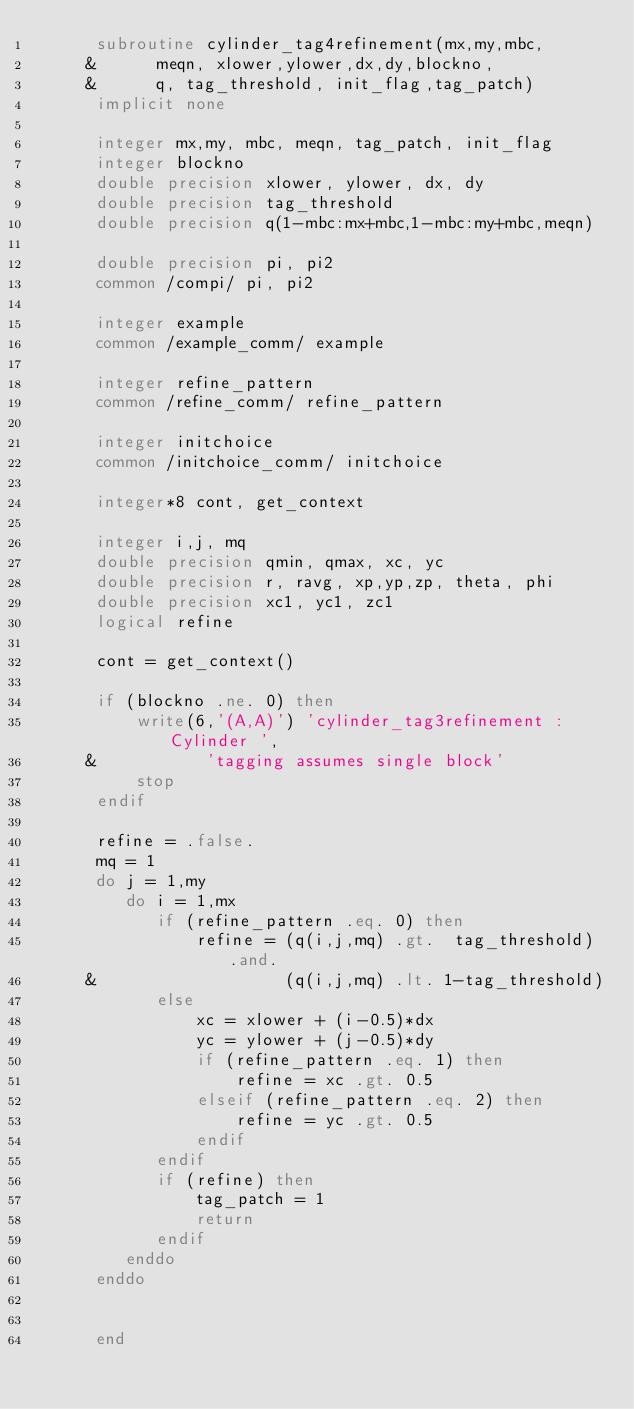<code> <loc_0><loc_0><loc_500><loc_500><_FORTRAN_>      subroutine cylinder_tag4refinement(mx,my,mbc,
     &      meqn, xlower,ylower,dx,dy,blockno,
     &      q, tag_threshold, init_flag,tag_patch)
      implicit none

      integer mx,my, mbc, meqn, tag_patch, init_flag
      integer blockno
      double precision xlower, ylower, dx, dy
      double precision tag_threshold
      double precision q(1-mbc:mx+mbc,1-mbc:my+mbc,meqn)

      double precision pi, pi2
      common /compi/ pi, pi2

      integer example
      common /example_comm/ example      

      integer refine_pattern
      common /refine_comm/ refine_pattern

      integer initchoice
      common /initchoice_comm/ initchoice

      integer*8 cont, get_context

      integer i,j, mq
      double precision qmin, qmax, xc, yc
      double precision r, ravg, xp,yp,zp, theta, phi
      double precision xc1, yc1, zc1
      logical refine

      cont = get_context()

      if (blockno .ne. 0) then
          write(6,'(A,A)') 'cylinder_tag3refinement : Cylinder ',
     &           'tagging assumes single block'
          stop
      endif

      refine = .false.
      mq = 1
      do j = 1,my
         do i = 1,mx
            if (refine_pattern .eq. 0) then
                refine = (q(i,j,mq) .gt.  tag_threshold) .and.
     &                   (q(i,j,mq) .lt. 1-tag_threshold)
            else
                xc = xlower + (i-0.5)*dx
                yc = ylower + (j-0.5)*dy
                if (refine_pattern .eq. 1) then
                    refine = xc .gt. 0.5
                elseif (refine_pattern .eq. 2) then
                    refine = yc .gt. 0.5
                endif
            endif
            if (refine) then
                tag_patch = 1
                return
            endif
         enddo
      enddo


      end
</code> 